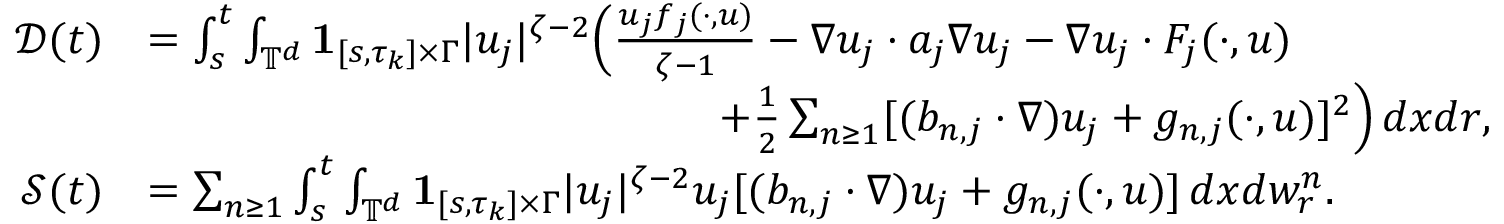Convert formula to latex. <formula><loc_0><loc_0><loc_500><loc_500>\begin{array} { r l r } { \mathcal { D } ( t ) } & { = \int _ { s } ^ { t } \int _ { { \mathbb { T } } ^ { d } } { 1 } _ { [ s , \tau _ { k } ] \times \Gamma } | u _ { j } | ^ { \zeta - 2 } \left ( \frac { u _ { j } f _ { j } ( \cdot , u ) } { \zeta - 1 } - \nabla u _ { j } \cdot a _ { j } \nabla u _ { j } - \nabla u _ { j } \cdot F _ { j } ( \cdot , u ) } \\ & { \quad + \frac { 1 } { 2 } \sum _ { n \geq 1 } [ ( b _ { n , j } \cdot \nabla ) u _ { j } + g _ { n , j } ( \cdot , u ) ] ^ { 2 } \right ) \, d x d r , } & \\ { \mathcal { S } ( t ) } & { = \sum _ { n \geq 1 } \int _ { s } ^ { t } \int _ { { \mathbb { T } } ^ { d } } { 1 } _ { [ s , \tau _ { k } ] \times \Gamma } | u _ { j } | ^ { \zeta - 2 } u _ { j } [ ( b _ { n , j } \cdot \nabla ) u _ { j } + g _ { n , j } ( \cdot , u ) ] \, d x d w _ { r } ^ { n } . } \end{array}</formula> 